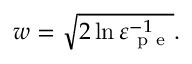Convert formula to latex. <formula><loc_0><loc_0><loc_500><loc_500>w = \sqrt { 2 \ln \varepsilon _ { p e } ^ { - 1 } } .</formula> 